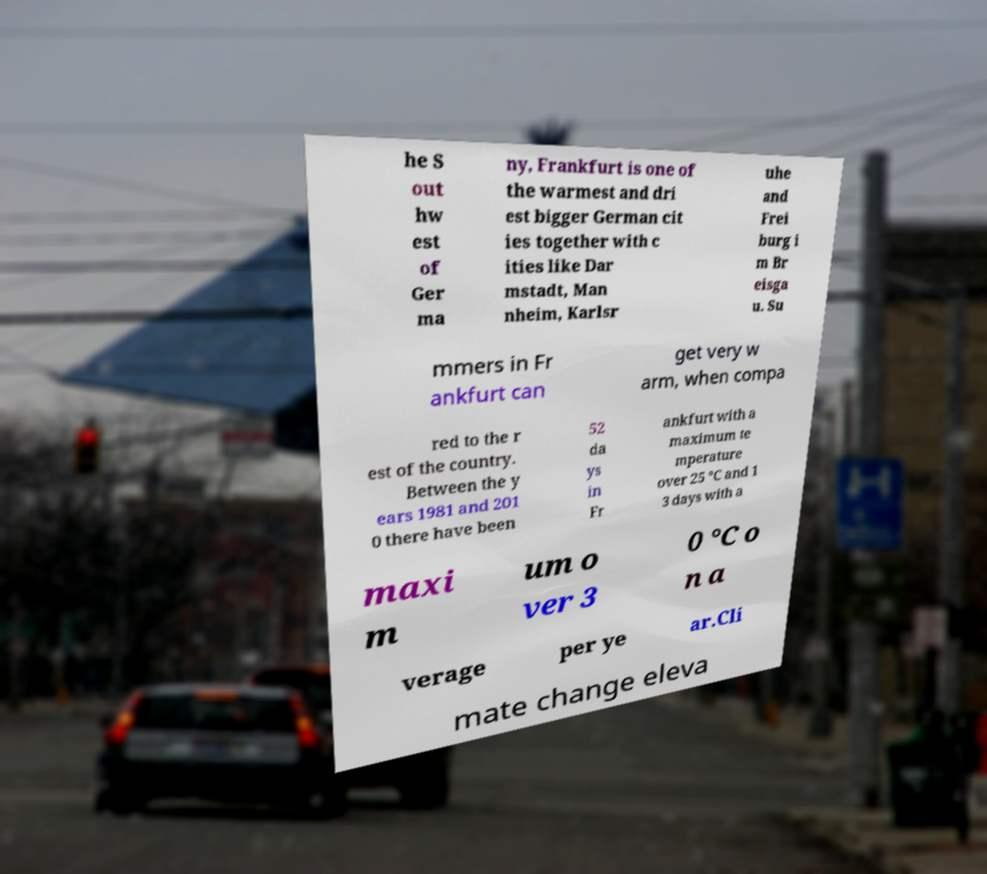Can you accurately transcribe the text from the provided image for me? he S out hw est of Ger ma ny, Frankfurt is one of the warmest and dri est bigger German cit ies together with c ities like Dar mstadt, Man nheim, Karlsr uhe and Frei burg i m Br eisga u. Su mmers in Fr ankfurt can get very w arm, when compa red to the r est of the country. Between the y ears 1981 and 201 0 there have been 52 da ys in Fr ankfurt with a maximum te mperature over 25 °C and 1 3 days with a maxi m um o ver 3 0 °C o n a verage per ye ar.Cli mate change eleva 